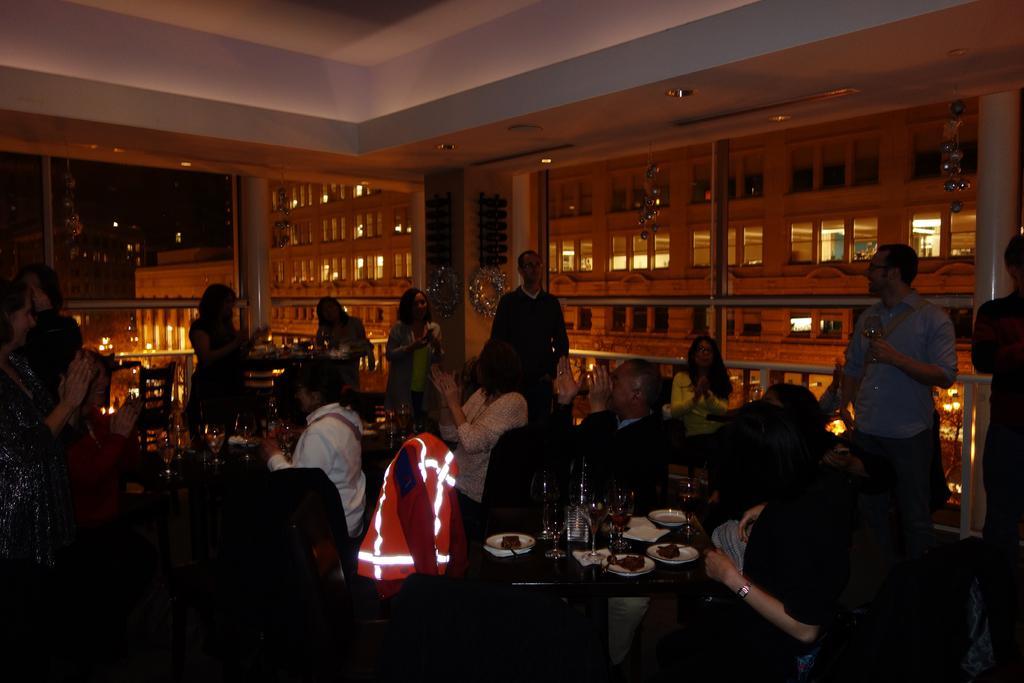Could you give a brief overview of what you see in this image? In this image I can see group of people some are sitting and some are standing. I can also see few plates, glasses on the table, background I can see few lights. 